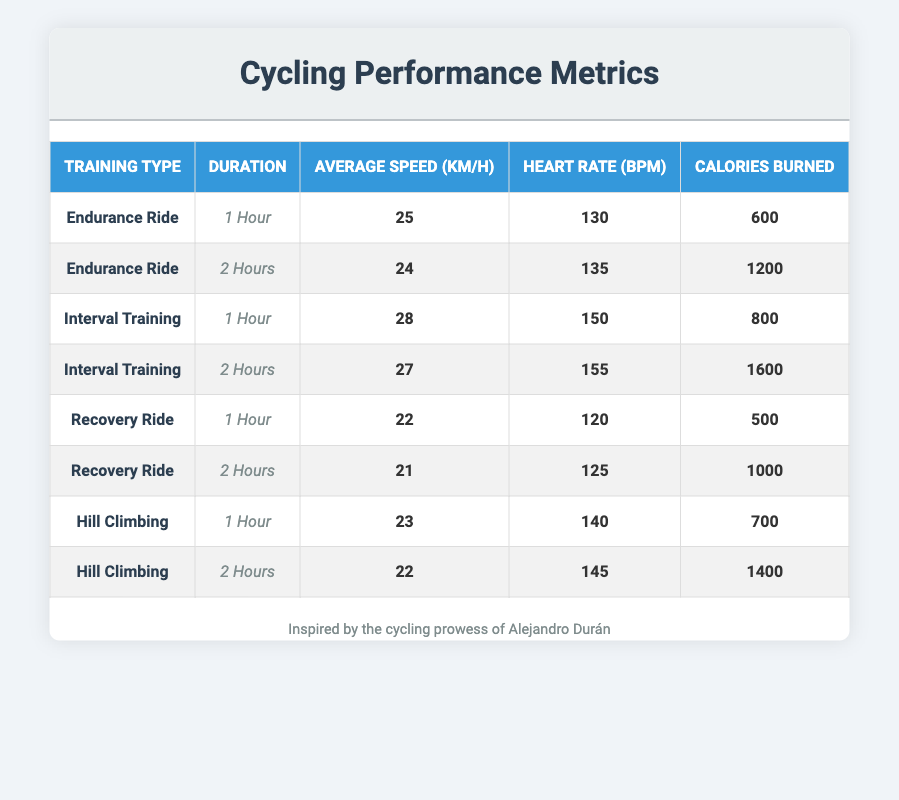What is the average speed for a 1-hour Endurance Ride? There is one data point for a 1-hour Endurance Ride with an average speed of 25 km/h. Since it's the only value, the average speed for this training type and duration is simply 25 km/h.
Answer: 25 km/h How many calories are burned during a 2-hour Interval Training session? The table shows that during a 2-hour Interval Training session, 1600 calories are burned, as indicated in the relevant row of the table.
Answer: 1600 calories True or False: The heart rate during a 1-hour Recovery Ride is higher than that of a 1-hour Endurance Ride. The heart rate for a 1-hour Recovery Ride is 120 bpm, while for a 1-hour Endurance Ride it is 130 bpm. Since 120 is less than 130, the statement is false.
Answer: False What is the total number of calories burned from both 1-hour and 2-hour Hill Climbing sessions? For the 1-hour Hill Climbing session, 700 calories are burned, and for the 2-hour session, 1400 calories are burned. Adding these values gives us 700 + 1400 = 2100 calories.
Answer: 2100 calories What is the heart rate difference between a 1-hour Interval Training and a 1-hour Endurance Ride? The heart rate for a 1-hour Interval Training is 150 bpm, and for a 1-hour Endurance Ride, it is 130 bpm. The difference is calculated as 150 - 130 = 20 bpm.
Answer: 20 bpm Which training type has the highest average speed for a 2-hour session? Examining the table, the average speed for 2-hour sessions is 24 km/h for Endurance Ride, 27 km/h for Interval Training, 21 km/h for Recovery Ride, and 22 km/h for Hill Climbing. The highest average speed is 27 km/h for Interval Training.
Answer: Interval Training What is the average number of calories burned per hour for an Endurance Ride? There are two sessions for Endurance Ride: 600 calories for 1 hour and 1200 calories for 2 hours. To find the average, we sum 600 + 1200 = 1800 calories, then divide by 2 (the number of sessions): 1800 / 2 = 900 calories per hour.
Answer: 900 calories per hour Which training type has the lowest average heart rate across both durations? The heart rates for both durations of the four training types are Endurance Ride (130, 135), Interval Training (150, 155), Recovery Ride (120, 125), and Hill Climbing (140, 145). The lowest heart rate is 120 bpm for the 1-hour Recovery Ride, making it the lowest average across both durations.
Answer: Recovery Ride 